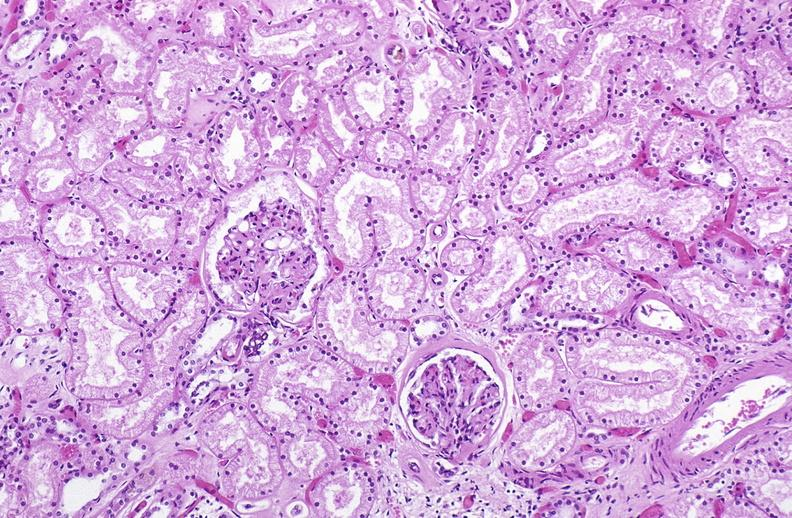s metastatic lung carcinoma present?
Answer the question using a single word or phrase. No 